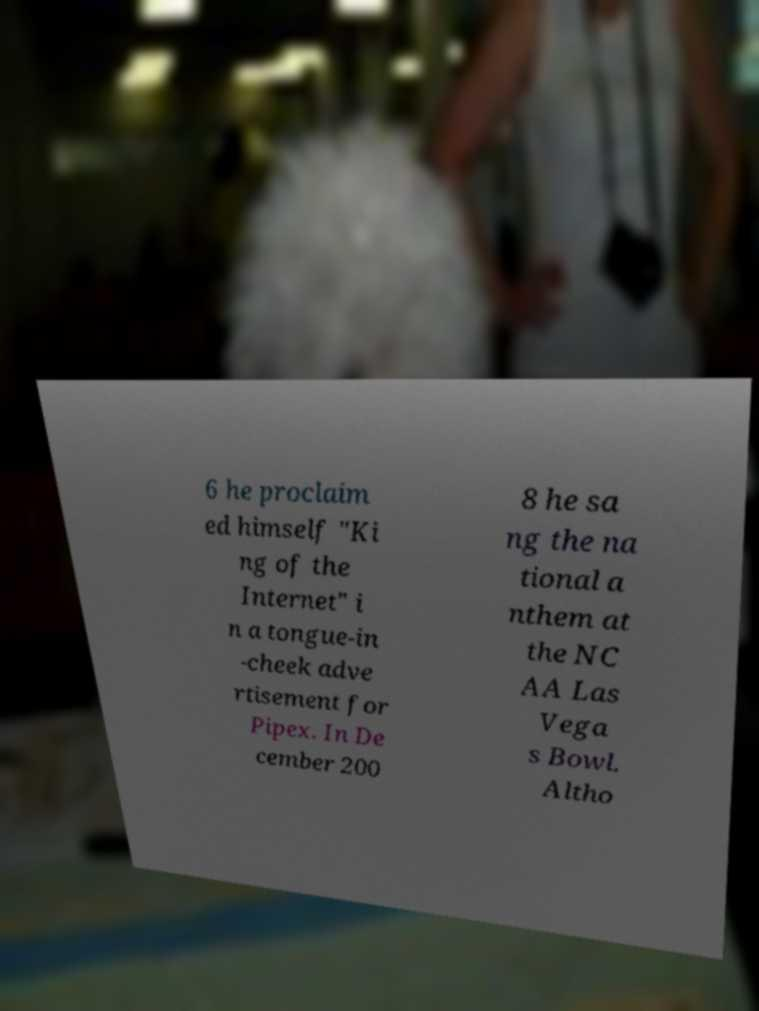I need the written content from this picture converted into text. Can you do that? 6 he proclaim ed himself "Ki ng of the Internet" i n a tongue-in -cheek adve rtisement for Pipex. In De cember 200 8 he sa ng the na tional a nthem at the NC AA Las Vega s Bowl. Altho 